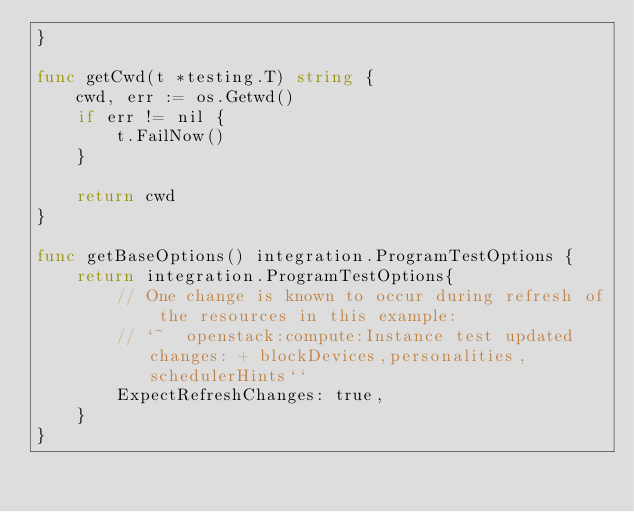<code> <loc_0><loc_0><loc_500><loc_500><_Go_>}

func getCwd(t *testing.T) string {
	cwd, err := os.Getwd()
	if err != nil {
		t.FailNow()
	}

	return cwd
}

func getBaseOptions() integration.ProgramTestOptions {
	return integration.ProgramTestOptions{
		// One change is known to occur during refresh of the resources in this example:
		// `~  openstack:compute:Instance test updated changes: + blockDevices,personalities,schedulerHints``
		ExpectRefreshChanges: true,
	}
}
</code> 